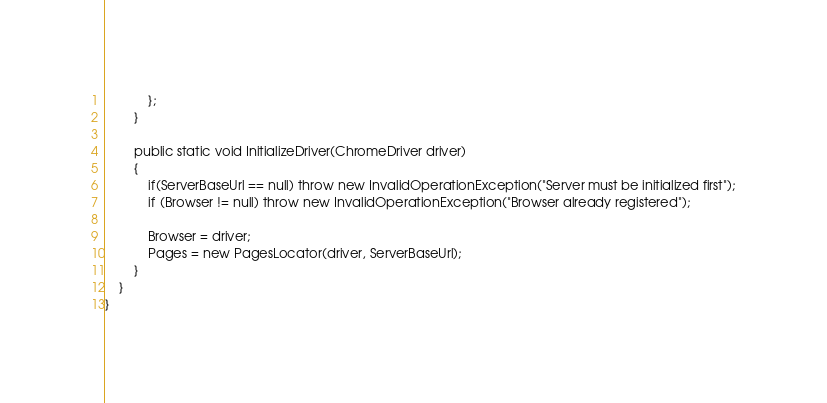<code> <loc_0><loc_0><loc_500><loc_500><_C#_>			};
		}

		public static void InitializeDriver(ChromeDriver driver)
		{
			if(ServerBaseUrl == null) throw new InvalidOperationException("Server must be initialized first");
			if (Browser != null) throw new InvalidOperationException("Browser already registered");

			Browser = driver;
			Pages = new PagesLocator(driver, ServerBaseUrl);
		}
	}
}
</code> 